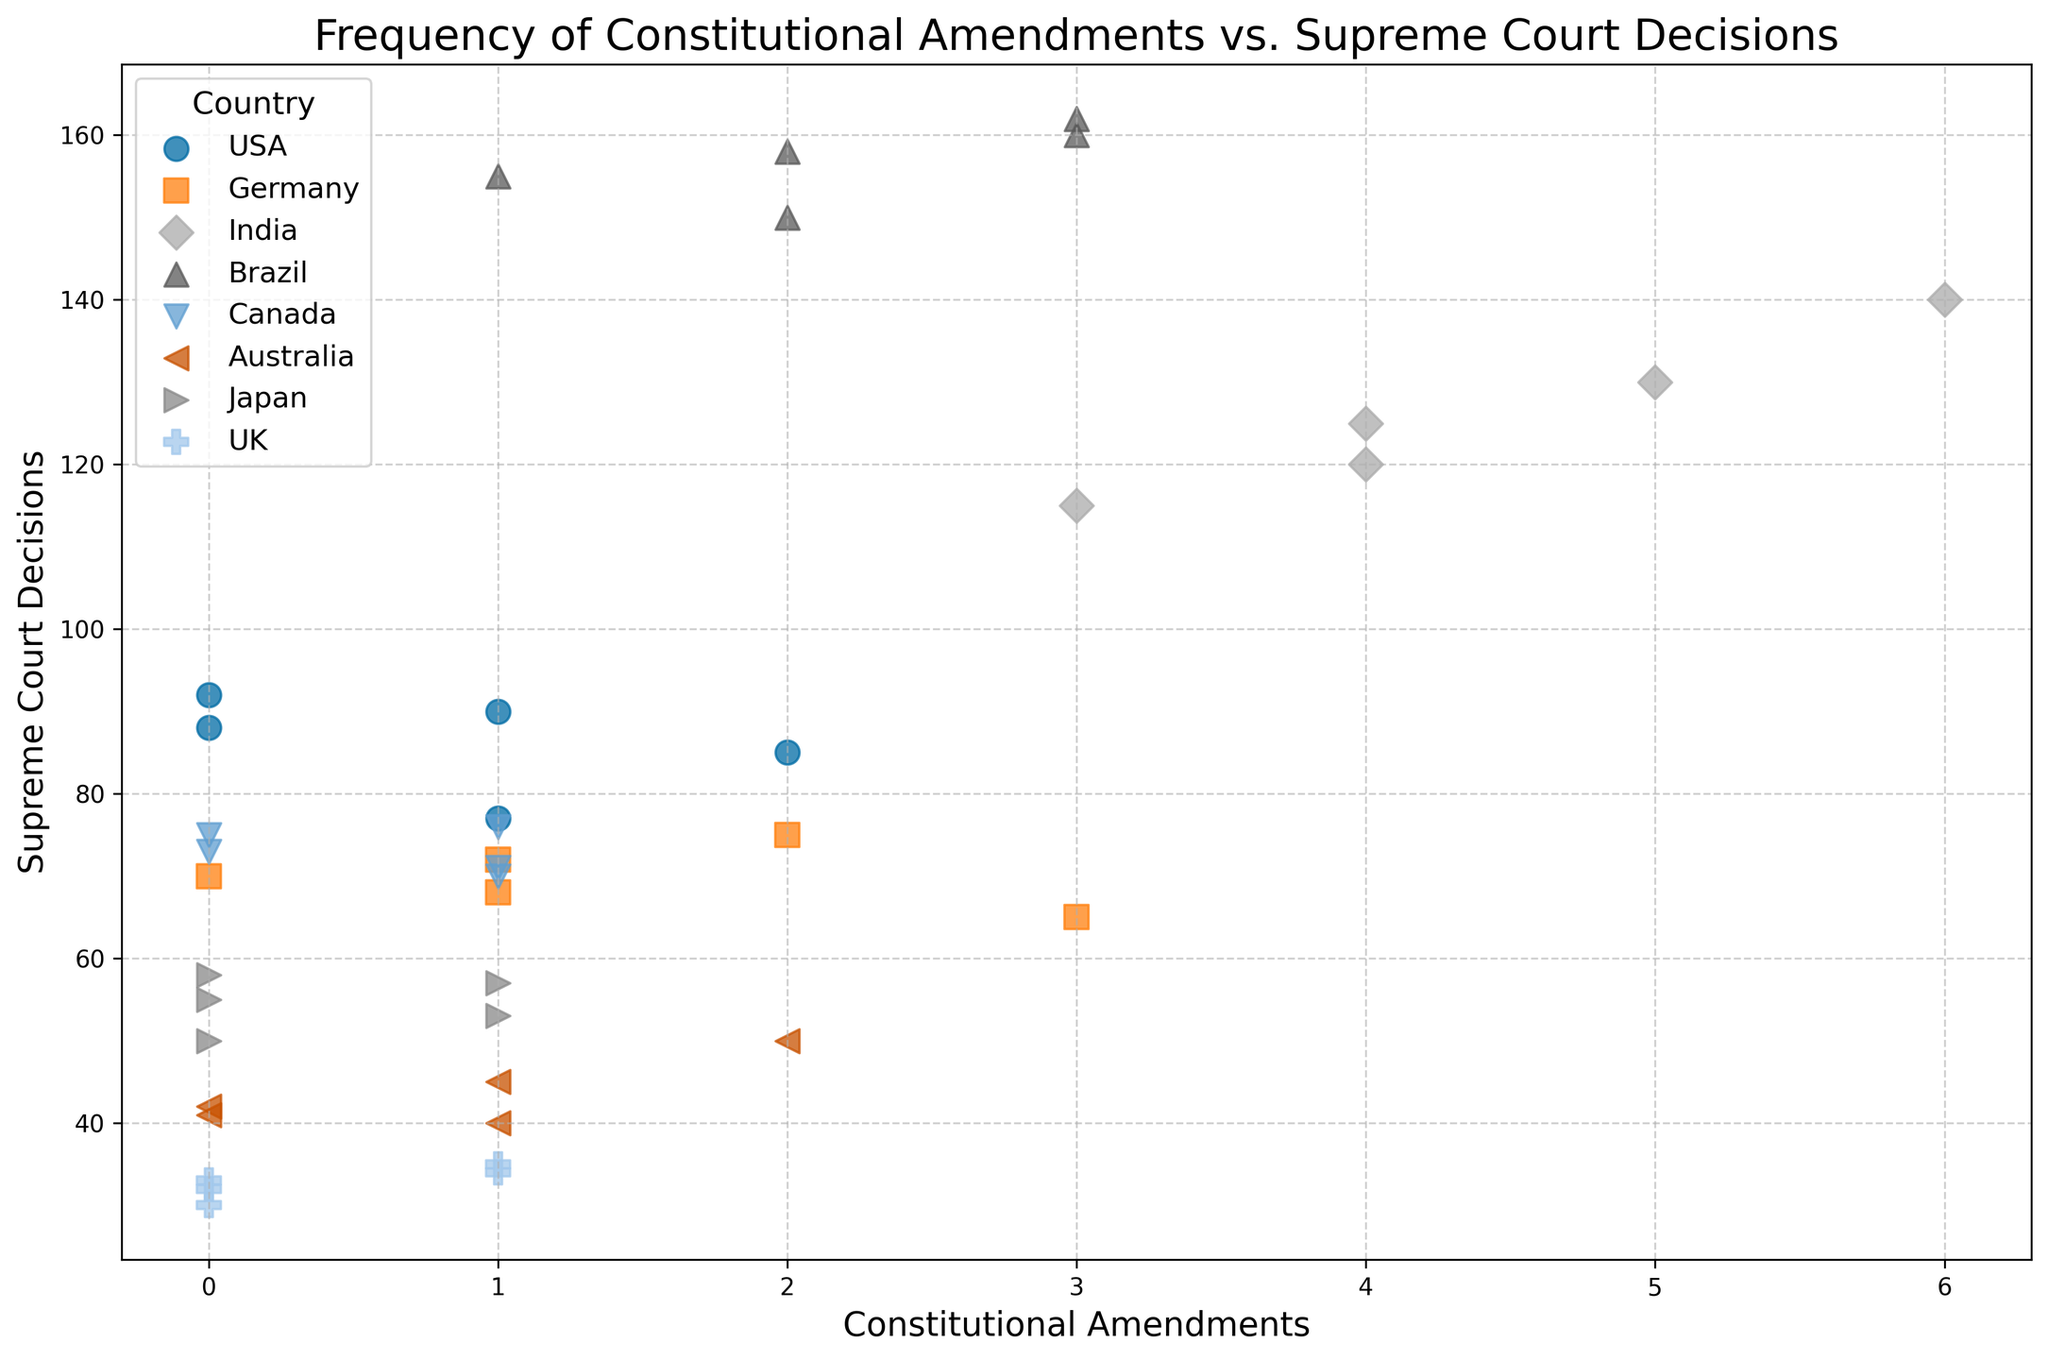Which country has the highest frequency of constitutional amendments in 2004? By visual inspection of the scatter plot, identify the country with the highest number of amendments in 2004, which can be found at the highest x-coordinate.
Answer: India Which country has the most Supreme Court decisions with zero constitutional amendments? Examine the scatter plot for points on the y-axis where the x-coordinate (amendments) is zero, then identify the one with the highest y-coordinate (Supreme Court decisions).
Answer: Brazil Is there a country where the number of Supreme Court decisions remains relatively stable over time? Analyze the scatter plot to see if any country has data points that are closely clustered along a horizontal line, indicating minimal variation in Supreme Court decisions.
Answer: USA Which country exhibits the most significant increase in Supreme Court decisions with the increase in constitutional amendments? Observe the scatter plot to identify which country has a visibly upward trend correlating the number of constitutional amendments with an increase in Supreme Court decisions.
Answer: India What are the average constitutional amendments and Supreme Court decisions for Brazil? Calculate the average by summing up the constitutional amendments and Supreme Court decisions for Brazil and dividing each sum by the number of years (5).
Answer: Amendments: 2.2, Decisions: 157 How do Supreme Court decisions in the USA compare to those in Germany for years with two constitutional amendments? Identify and compare the y-coordinates (Supreme Court decisions) for the USA and Germany where the x-coordinate (constitutional amendments) is two.
Answer: USA: 85, Germany: 75 Which country has data points that show a mix of 1 and 0 constitutional amendments but a relatively narrow range of Supreme Court decisions? Look for a country with x-coordinates of 1 and 0 that has data points closely packed along the y-axis, indicative of a narrow range of Supreme Court decisions.
Answer: Canada What is the combined total of constitutional amendments for Japan and the UK across all years shown? Sum the constitutional amendments for each year for both Japan and the UK and add the totals together.
Answer: 8 Are there any countries where the scatter plot shows no constitutional amendments for a particular year, and what is the corresponding number of Supreme Court decisions for those years? Look for data points where x (constitutional amendments) is zero and then identify the corresponding y-values (Supreme Court decisions).
Answer: USA: 92, Germany: 70, Canada: 73, Australia: 42, Japan: 50, UK: 33 